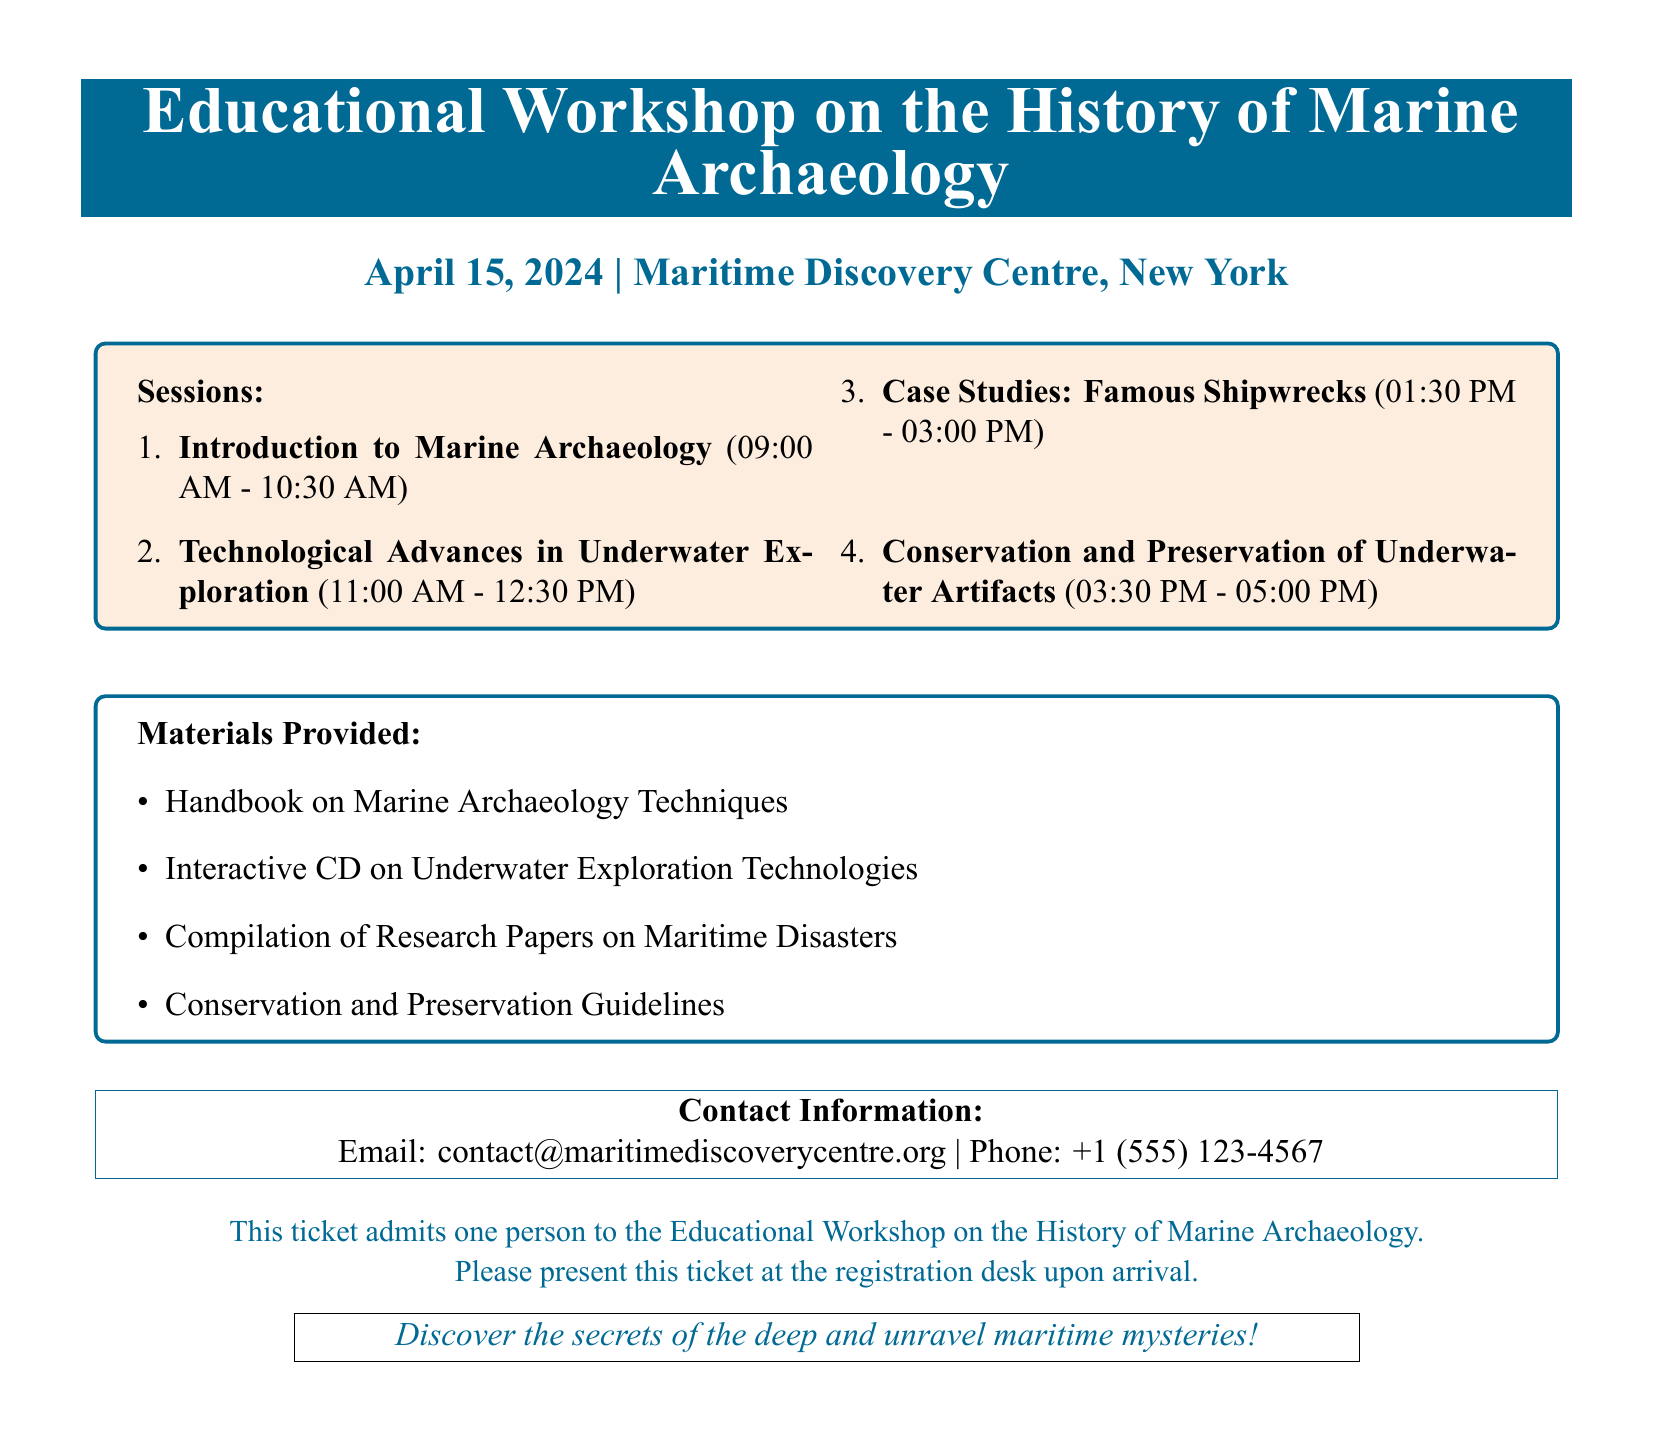What is the date of the workshop? The date of the workshop is explicitly stated in the document.
Answer: April 15, 2024 Where is the workshop being held? The location of the workshop is mentioned clearly in the document.
Answer: Maritime Discovery Centre, New York How many sessions are there in total? The number of sessions is indicated by counting the listed items under Sessions.
Answer: 4 What is the first session topic? The first session topic is the very first item listed under Sessions.
Answer: Introduction to Marine Archaeology What materials are provided as part of the workshop? The materials provided are listed under the section "Materials Provided."
Answer: Handbook on Marine Archaeology Techniques What is the email contact for the event? The document includes contact information, including the email.
Answer: contact@maritimediscoverycentre.org What time does the last session end? The ending time for the last session is derived from the schedule provided in the document.
Answer: 05:00 PM What is the theme of this workshop? The focus of the workshop is described at the top of the document.
Answer: History of Marine Archaeology 